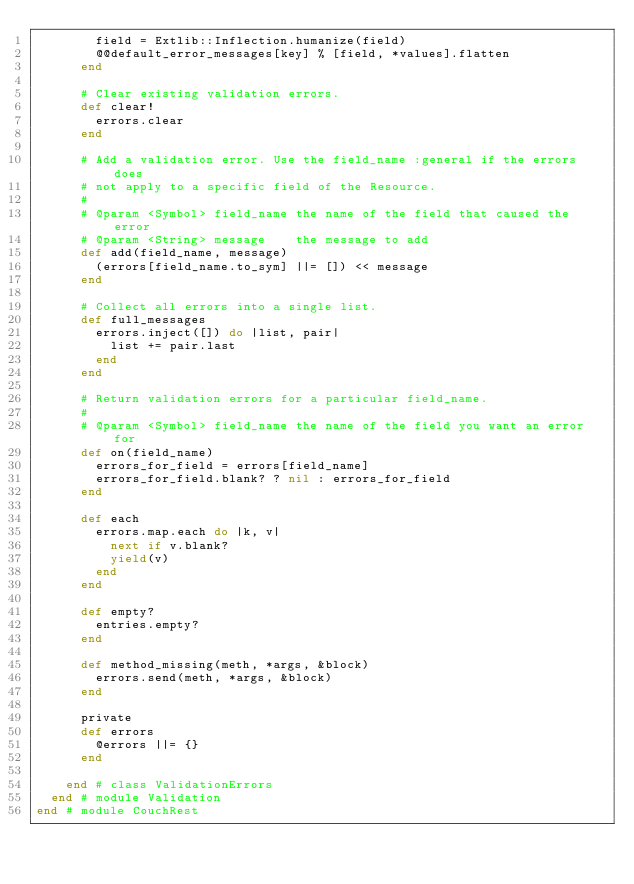Convert code to text. <code><loc_0><loc_0><loc_500><loc_500><_Ruby_>        field = Extlib::Inflection.humanize(field)
        @@default_error_messages[key] % [field, *values].flatten
      end

      # Clear existing validation errors.
      def clear!
        errors.clear
      end

      # Add a validation error. Use the field_name :general if the errors does
      # not apply to a specific field of the Resource.
      #
      # @param <Symbol> field_name the name of the field that caused the error
      # @param <String> message    the message to add
      def add(field_name, message)
        (errors[field_name.to_sym] ||= []) << message
      end

      # Collect all errors into a single list.
      def full_messages
        errors.inject([]) do |list, pair|
          list += pair.last
        end
      end

      # Return validation errors for a particular field_name.
      #
      # @param <Symbol> field_name the name of the field you want an error for
      def on(field_name)
        errors_for_field = errors[field_name]
        errors_for_field.blank? ? nil : errors_for_field
      end

      def each
        errors.map.each do |k, v|
          next if v.blank?
          yield(v)
        end
      end

      def empty?
        entries.empty?
      end

      def method_missing(meth, *args, &block)
        errors.send(meth, *args, &block)
      end

      private
      def errors
        @errors ||= {}
      end

    end # class ValidationErrors
  end # module Validation
end # module CouchRest
</code> 